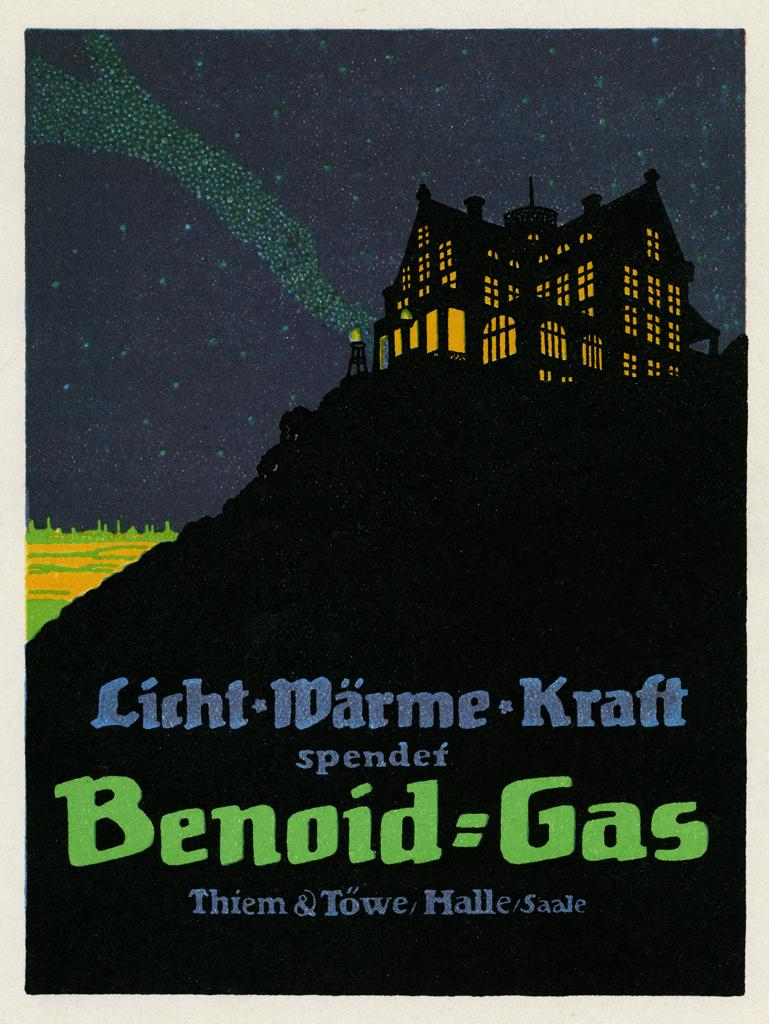<image>
Describe the image concisely. Cover showing a house with the words "Benoid Gas" in green. 